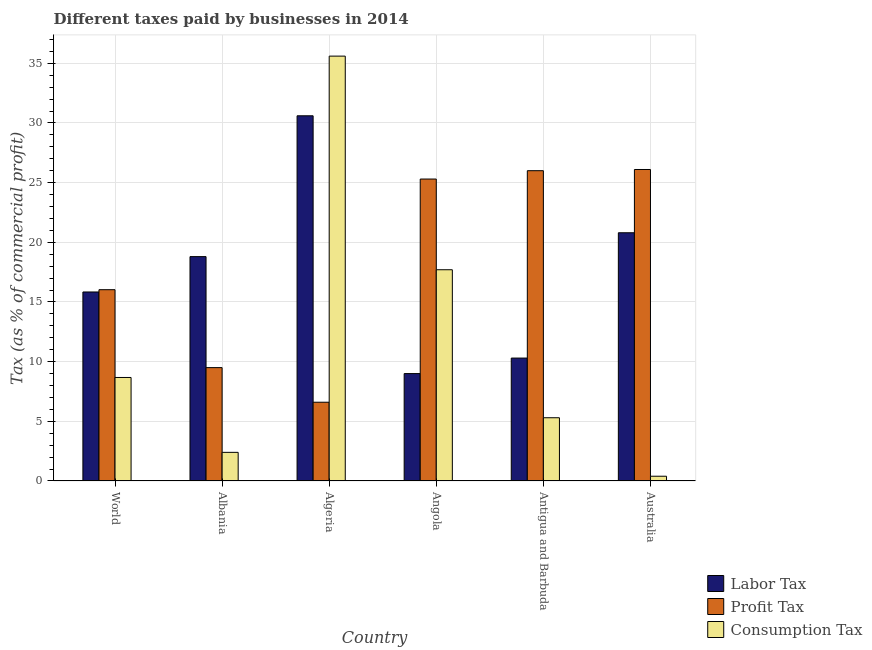How many different coloured bars are there?
Provide a short and direct response. 3. How many groups of bars are there?
Provide a short and direct response. 6. What is the label of the 4th group of bars from the left?
Give a very brief answer. Angola. What is the percentage of consumption tax in World?
Provide a short and direct response. 8.67. Across all countries, what is the maximum percentage of profit tax?
Your answer should be compact. 26.1. In which country was the percentage of consumption tax maximum?
Give a very brief answer. Algeria. In which country was the percentage of profit tax minimum?
Keep it short and to the point. Algeria. What is the total percentage of profit tax in the graph?
Make the answer very short. 109.53. What is the difference between the percentage of labor tax in Albania and that in Australia?
Make the answer very short. -2. What is the difference between the percentage of consumption tax in Algeria and the percentage of profit tax in Albania?
Offer a terse response. 26.1. What is the average percentage of profit tax per country?
Provide a short and direct response. 18.25. What is the difference between the percentage of consumption tax and percentage of labor tax in Australia?
Your answer should be compact. -20.4. What is the ratio of the percentage of consumption tax in Angola to that in Antigua and Barbuda?
Offer a very short reply. 3.34. Is the percentage of profit tax in Australia less than that in World?
Keep it short and to the point. No. Is the difference between the percentage of consumption tax in Algeria and Australia greater than the difference between the percentage of labor tax in Algeria and Australia?
Make the answer very short. Yes. What is the difference between the highest and the second highest percentage of profit tax?
Provide a short and direct response. 0.1. What is the difference between the highest and the lowest percentage of labor tax?
Your response must be concise. 21.6. In how many countries, is the percentage of profit tax greater than the average percentage of profit tax taken over all countries?
Your answer should be compact. 3. Is the sum of the percentage of consumption tax in Angola and World greater than the maximum percentage of labor tax across all countries?
Provide a short and direct response. No. What does the 1st bar from the left in Australia represents?
Provide a succinct answer. Labor Tax. What does the 1st bar from the right in Albania represents?
Offer a very short reply. Consumption Tax. How many bars are there?
Give a very brief answer. 18. How many countries are there in the graph?
Your answer should be compact. 6. What is the difference between two consecutive major ticks on the Y-axis?
Ensure brevity in your answer.  5. Are the values on the major ticks of Y-axis written in scientific E-notation?
Your answer should be compact. No. How many legend labels are there?
Your answer should be compact. 3. What is the title of the graph?
Keep it short and to the point. Different taxes paid by businesses in 2014. Does "Transport equipments" appear as one of the legend labels in the graph?
Offer a terse response. No. What is the label or title of the X-axis?
Your response must be concise. Country. What is the label or title of the Y-axis?
Provide a succinct answer. Tax (as % of commercial profit). What is the Tax (as % of commercial profit) of Labor Tax in World?
Keep it short and to the point. 15.84. What is the Tax (as % of commercial profit) in Profit Tax in World?
Give a very brief answer. 16.03. What is the Tax (as % of commercial profit) of Consumption Tax in World?
Provide a succinct answer. 8.67. What is the Tax (as % of commercial profit) of Labor Tax in Albania?
Make the answer very short. 18.8. What is the Tax (as % of commercial profit) of Consumption Tax in Albania?
Give a very brief answer. 2.4. What is the Tax (as % of commercial profit) of Labor Tax in Algeria?
Make the answer very short. 30.6. What is the Tax (as % of commercial profit) of Consumption Tax in Algeria?
Provide a short and direct response. 35.6. What is the Tax (as % of commercial profit) in Labor Tax in Angola?
Make the answer very short. 9. What is the Tax (as % of commercial profit) of Profit Tax in Angola?
Your response must be concise. 25.3. What is the Tax (as % of commercial profit) of Consumption Tax in Angola?
Your answer should be compact. 17.7. What is the Tax (as % of commercial profit) of Labor Tax in Antigua and Barbuda?
Provide a succinct answer. 10.3. What is the Tax (as % of commercial profit) of Profit Tax in Antigua and Barbuda?
Keep it short and to the point. 26. What is the Tax (as % of commercial profit) in Consumption Tax in Antigua and Barbuda?
Provide a succinct answer. 5.3. What is the Tax (as % of commercial profit) of Labor Tax in Australia?
Give a very brief answer. 20.8. What is the Tax (as % of commercial profit) in Profit Tax in Australia?
Make the answer very short. 26.1. What is the Tax (as % of commercial profit) of Consumption Tax in Australia?
Your answer should be very brief. 0.4. Across all countries, what is the maximum Tax (as % of commercial profit) of Labor Tax?
Offer a terse response. 30.6. Across all countries, what is the maximum Tax (as % of commercial profit) in Profit Tax?
Your response must be concise. 26.1. Across all countries, what is the maximum Tax (as % of commercial profit) of Consumption Tax?
Offer a terse response. 35.6. Across all countries, what is the minimum Tax (as % of commercial profit) of Profit Tax?
Give a very brief answer. 6.6. Across all countries, what is the minimum Tax (as % of commercial profit) in Consumption Tax?
Offer a very short reply. 0.4. What is the total Tax (as % of commercial profit) in Labor Tax in the graph?
Your answer should be very brief. 105.34. What is the total Tax (as % of commercial profit) in Profit Tax in the graph?
Your response must be concise. 109.53. What is the total Tax (as % of commercial profit) in Consumption Tax in the graph?
Your answer should be compact. 70.07. What is the difference between the Tax (as % of commercial profit) of Labor Tax in World and that in Albania?
Give a very brief answer. -2.96. What is the difference between the Tax (as % of commercial profit) in Profit Tax in World and that in Albania?
Your answer should be compact. 6.53. What is the difference between the Tax (as % of commercial profit) in Consumption Tax in World and that in Albania?
Ensure brevity in your answer.  6.27. What is the difference between the Tax (as % of commercial profit) in Labor Tax in World and that in Algeria?
Make the answer very short. -14.76. What is the difference between the Tax (as % of commercial profit) in Profit Tax in World and that in Algeria?
Your answer should be very brief. 9.43. What is the difference between the Tax (as % of commercial profit) in Consumption Tax in World and that in Algeria?
Provide a succinct answer. -26.93. What is the difference between the Tax (as % of commercial profit) of Labor Tax in World and that in Angola?
Ensure brevity in your answer.  6.84. What is the difference between the Tax (as % of commercial profit) of Profit Tax in World and that in Angola?
Keep it short and to the point. -9.27. What is the difference between the Tax (as % of commercial profit) of Consumption Tax in World and that in Angola?
Your answer should be compact. -9.03. What is the difference between the Tax (as % of commercial profit) in Labor Tax in World and that in Antigua and Barbuda?
Your answer should be very brief. 5.54. What is the difference between the Tax (as % of commercial profit) in Profit Tax in World and that in Antigua and Barbuda?
Your answer should be very brief. -9.97. What is the difference between the Tax (as % of commercial profit) of Consumption Tax in World and that in Antigua and Barbuda?
Your answer should be very brief. 3.37. What is the difference between the Tax (as % of commercial profit) of Labor Tax in World and that in Australia?
Your response must be concise. -4.96. What is the difference between the Tax (as % of commercial profit) in Profit Tax in World and that in Australia?
Offer a terse response. -10.07. What is the difference between the Tax (as % of commercial profit) in Consumption Tax in World and that in Australia?
Your answer should be very brief. 8.27. What is the difference between the Tax (as % of commercial profit) of Labor Tax in Albania and that in Algeria?
Provide a short and direct response. -11.8. What is the difference between the Tax (as % of commercial profit) in Consumption Tax in Albania and that in Algeria?
Offer a terse response. -33.2. What is the difference between the Tax (as % of commercial profit) in Profit Tax in Albania and that in Angola?
Keep it short and to the point. -15.8. What is the difference between the Tax (as % of commercial profit) of Consumption Tax in Albania and that in Angola?
Make the answer very short. -15.3. What is the difference between the Tax (as % of commercial profit) in Labor Tax in Albania and that in Antigua and Barbuda?
Offer a terse response. 8.5. What is the difference between the Tax (as % of commercial profit) of Profit Tax in Albania and that in Antigua and Barbuda?
Ensure brevity in your answer.  -16.5. What is the difference between the Tax (as % of commercial profit) of Profit Tax in Albania and that in Australia?
Offer a terse response. -16.6. What is the difference between the Tax (as % of commercial profit) in Consumption Tax in Albania and that in Australia?
Offer a terse response. 2. What is the difference between the Tax (as % of commercial profit) of Labor Tax in Algeria and that in Angola?
Your response must be concise. 21.6. What is the difference between the Tax (as % of commercial profit) of Profit Tax in Algeria and that in Angola?
Your answer should be very brief. -18.7. What is the difference between the Tax (as % of commercial profit) of Labor Tax in Algeria and that in Antigua and Barbuda?
Give a very brief answer. 20.3. What is the difference between the Tax (as % of commercial profit) of Profit Tax in Algeria and that in Antigua and Barbuda?
Make the answer very short. -19.4. What is the difference between the Tax (as % of commercial profit) of Consumption Tax in Algeria and that in Antigua and Barbuda?
Offer a very short reply. 30.3. What is the difference between the Tax (as % of commercial profit) in Profit Tax in Algeria and that in Australia?
Keep it short and to the point. -19.5. What is the difference between the Tax (as % of commercial profit) in Consumption Tax in Algeria and that in Australia?
Offer a terse response. 35.2. What is the difference between the Tax (as % of commercial profit) in Labor Tax in Angola and that in Antigua and Barbuda?
Ensure brevity in your answer.  -1.3. What is the difference between the Tax (as % of commercial profit) of Profit Tax in Angola and that in Antigua and Barbuda?
Make the answer very short. -0.7. What is the difference between the Tax (as % of commercial profit) of Consumption Tax in Angola and that in Antigua and Barbuda?
Provide a short and direct response. 12.4. What is the difference between the Tax (as % of commercial profit) of Consumption Tax in Angola and that in Australia?
Offer a very short reply. 17.3. What is the difference between the Tax (as % of commercial profit) in Labor Tax in Antigua and Barbuda and that in Australia?
Provide a succinct answer. -10.5. What is the difference between the Tax (as % of commercial profit) in Labor Tax in World and the Tax (as % of commercial profit) in Profit Tax in Albania?
Give a very brief answer. 6.34. What is the difference between the Tax (as % of commercial profit) in Labor Tax in World and the Tax (as % of commercial profit) in Consumption Tax in Albania?
Your answer should be very brief. 13.44. What is the difference between the Tax (as % of commercial profit) in Profit Tax in World and the Tax (as % of commercial profit) in Consumption Tax in Albania?
Your response must be concise. 13.63. What is the difference between the Tax (as % of commercial profit) of Labor Tax in World and the Tax (as % of commercial profit) of Profit Tax in Algeria?
Provide a short and direct response. 9.24. What is the difference between the Tax (as % of commercial profit) in Labor Tax in World and the Tax (as % of commercial profit) in Consumption Tax in Algeria?
Provide a succinct answer. -19.76. What is the difference between the Tax (as % of commercial profit) of Profit Tax in World and the Tax (as % of commercial profit) of Consumption Tax in Algeria?
Give a very brief answer. -19.57. What is the difference between the Tax (as % of commercial profit) in Labor Tax in World and the Tax (as % of commercial profit) in Profit Tax in Angola?
Provide a succinct answer. -9.46. What is the difference between the Tax (as % of commercial profit) in Labor Tax in World and the Tax (as % of commercial profit) in Consumption Tax in Angola?
Offer a very short reply. -1.86. What is the difference between the Tax (as % of commercial profit) of Profit Tax in World and the Tax (as % of commercial profit) of Consumption Tax in Angola?
Make the answer very short. -1.67. What is the difference between the Tax (as % of commercial profit) of Labor Tax in World and the Tax (as % of commercial profit) of Profit Tax in Antigua and Barbuda?
Provide a short and direct response. -10.16. What is the difference between the Tax (as % of commercial profit) of Labor Tax in World and the Tax (as % of commercial profit) of Consumption Tax in Antigua and Barbuda?
Provide a succinct answer. 10.54. What is the difference between the Tax (as % of commercial profit) of Profit Tax in World and the Tax (as % of commercial profit) of Consumption Tax in Antigua and Barbuda?
Offer a terse response. 10.73. What is the difference between the Tax (as % of commercial profit) in Labor Tax in World and the Tax (as % of commercial profit) in Profit Tax in Australia?
Ensure brevity in your answer.  -10.26. What is the difference between the Tax (as % of commercial profit) in Labor Tax in World and the Tax (as % of commercial profit) in Consumption Tax in Australia?
Keep it short and to the point. 15.44. What is the difference between the Tax (as % of commercial profit) of Profit Tax in World and the Tax (as % of commercial profit) of Consumption Tax in Australia?
Offer a terse response. 15.63. What is the difference between the Tax (as % of commercial profit) in Labor Tax in Albania and the Tax (as % of commercial profit) in Profit Tax in Algeria?
Your response must be concise. 12.2. What is the difference between the Tax (as % of commercial profit) in Labor Tax in Albania and the Tax (as % of commercial profit) in Consumption Tax in Algeria?
Your answer should be very brief. -16.8. What is the difference between the Tax (as % of commercial profit) of Profit Tax in Albania and the Tax (as % of commercial profit) of Consumption Tax in Algeria?
Give a very brief answer. -26.1. What is the difference between the Tax (as % of commercial profit) in Profit Tax in Albania and the Tax (as % of commercial profit) in Consumption Tax in Angola?
Ensure brevity in your answer.  -8.2. What is the difference between the Tax (as % of commercial profit) in Labor Tax in Albania and the Tax (as % of commercial profit) in Consumption Tax in Antigua and Barbuda?
Provide a short and direct response. 13.5. What is the difference between the Tax (as % of commercial profit) in Profit Tax in Albania and the Tax (as % of commercial profit) in Consumption Tax in Antigua and Barbuda?
Your answer should be very brief. 4.2. What is the difference between the Tax (as % of commercial profit) in Labor Tax in Albania and the Tax (as % of commercial profit) in Profit Tax in Australia?
Offer a very short reply. -7.3. What is the difference between the Tax (as % of commercial profit) in Labor Tax in Albania and the Tax (as % of commercial profit) in Consumption Tax in Australia?
Keep it short and to the point. 18.4. What is the difference between the Tax (as % of commercial profit) of Profit Tax in Albania and the Tax (as % of commercial profit) of Consumption Tax in Australia?
Provide a short and direct response. 9.1. What is the difference between the Tax (as % of commercial profit) of Labor Tax in Algeria and the Tax (as % of commercial profit) of Profit Tax in Angola?
Provide a succinct answer. 5.3. What is the difference between the Tax (as % of commercial profit) in Labor Tax in Algeria and the Tax (as % of commercial profit) in Consumption Tax in Angola?
Offer a terse response. 12.9. What is the difference between the Tax (as % of commercial profit) in Profit Tax in Algeria and the Tax (as % of commercial profit) in Consumption Tax in Angola?
Your answer should be compact. -11.1. What is the difference between the Tax (as % of commercial profit) in Labor Tax in Algeria and the Tax (as % of commercial profit) in Consumption Tax in Antigua and Barbuda?
Provide a succinct answer. 25.3. What is the difference between the Tax (as % of commercial profit) in Profit Tax in Algeria and the Tax (as % of commercial profit) in Consumption Tax in Antigua and Barbuda?
Offer a very short reply. 1.3. What is the difference between the Tax (as % of commercial profit) in Labor Tax in Algeria and the Tax (as % of commercial profit) in Consumption Tax in Australia?
Offer a terse response. 30.2. What is the difference between the Tax (as % of commercial profit) of Labor Tax in Angola and the Tax (as % of commercial profit) of Profit Tax in Antigua and Barbuda?
Ensure brevity in your answer.  -17. What is the difference between the Tax (as % of commercial profit) in Labor Tax in Angola and the Tax (as % of commercial profit) in Profit Tax in Australia?
Give a very brief answer. -17.1. What is the difference between the Tax (as % of commercial profit) of Profit Tax in Angola and the Tax (as % of commercial profit) of Consumption Tax in Australia?
Make the answer very short. 24.9. What is the difference between the Tax (as % of commercial profit) of Labor Tax in Antigua and Barbuda and the Tax (as % of commercial profit) of Profit Tax in Australia?
Give a very brief answer. -15.8. What is the difference between the Tax (as % of commercial profit) of Labor Tax in Antigua and Barbuda and the Tax (as % of commercial profit) of Consumption Tax in Australia?
Your answer should be compact. 9.9. What is the difference between the Tax (as % of commercial profit) in Profit Tax in Antigua and Barbuda and the Tax (as % of commercial profit) in Consumption Tax in Australia?
Offer a very short reply. 25.6. What is the average Tax (as % of commercial profit) of Labor Tax per country?
Give a very brief answer. 17.56. What is the average Tax (as % of commercial profit) in Profit Tax per country?
Your answer should be compact. 18.25. What is the average Tax (as % of commercial profit) of Consumption Tax per country?
Provide a succinct answer. 11.68. What is the difference between the Tax (as % of commercial profit) in Labor Tax and Tax (as % of commercial profit) in Profit Tax in World?
Provide a short and direct response. -0.19. What is the difference between the Tax (as % of commercial profit) of Labor Tax and Tax (as % of commercial profit) of Consumption Tax in World?
Offer a terse response. 7.16. What is the difference between the Tax (as % of commercial profit) in Profit Tax and Tax (as % of commercial profit) in Consumption Tax in World?
Provide a succinct answer. 7.36. What is the difference between the Tax (as % of commercial profit) of Labor Tax and Tax (as % of commercial profit) of Consumption Tax in Albania?
Your answer should be very brief. 16.4. What is the difference between the Tax (as % of commercial profit) in Profit Tax and Tax (as % of commercial profit) in Consumption Tax in Albania?
Offer a very short reply. 7.1. What is the difference between the Tax (as % of commercial profit) in Labor Tax and Tax (as % of commercial profit) in Profit Tax in Algeria?
Provide a short and direct response. 24. What is the difference between the Tax (as % of commercial profit) of Labor Tax and Tax (as % of commercial profit) of Consumption Tax in Algeria?
Your answer should be very brief. -5. What is the difference between the Tax (as % of commercial profit) in Profit Tax and Tax (as % of commercial profit) in Consumption Tax in Algeria?
Your response must be concise. -29. What is the difference between the Tax (as % of commercial profit) of Labor Tax and Tax (as % of commercial profit) of Profit Tax in Angola?
Give a very brief answer. -16.3. What is the difference between the Tax (as % of commercial profit) in Labor Tax and Tax (as % of commercial profit) in Consumption Tax in Angola?
Your answer should be compact. -8.7. What is the difference between the Tax (as % of commercial profit) in Profit Tax and Tax (as % of commercial profit) in Consumption Tax in Angola?
Ensure brevity in your answer.  7.6. What is the difference between the Tax (as % of commercial profit) of Labor Tax and Tax (as % of commercial profit) of Profit Tax in Antigua and Barbuda?
Your answer should be compact. -15.7. What is the difference between the Tax (as % of commercial profit) in Labor Tax and Tax (as % of commercial profit) in Consumption Tax in Antigua and Barbuda?
Make the answer very short. 5. What is the difference between the Tax (as % of commercial profit) in Profit Tax and Tax (as % of commercial profit) in Consumption Tax in Antigua and Barbuda?
Your answer should be very brief. 20.7. What is the difference between the Tax (as % of commercial profit) in Labor Tax and Tax (as % of commercial profit) in Consumption Tax in Australia?
Offer a terse response. 20.4. What is the difference between the Tax (as % of commercial profit) in Profit Tax and Tax (as % of commercial profit) in Consumption Tax in Australia?
Your answer should be very brief. 25.7. What is the ratio of the Tax (as % of commercial profit) of Labor Tax in World to that in Albania?
Offer a terse response. 0.84. What is the ratio of the Tax (as % of commercial profit) of Profit Tax in World to that in Albania?
Provide a short and direct response. 1.69. What is the ratio of the Tax (as % of commercial profit) in Consumption Tax in World to that in Albania?
Your answer should be very brief. 3.61. What is the ratio of the Tax (as % of commercial profit) of Labor Tax in World to that in Algeria?
Offer a very short reply. 0.52. What is the ratio of the Tax (as % of commercial profit) in Profit Tax in World to that in Algeria?
Provide a short and direct response. 2.43. What is the ratio of the Tax (as % of commercial profit) of Consumption Tax in World to that in Algeria?
Offer a very short reply. 0.24. What is the ratio of the Tax (as % of commercial profit) of Labor Tax in World to that in Angola?
Provide a succinct answer. 1.76. What is the ratio of the Tax (as % of commercial profit) in Profit Tax in World to that in Angola?
Provide a short and direct response. 0.63. What is the ratio of the Tax (as % of commercial profit) of Consumption Tax in World to that in Angola?
Offer a very short reply. 0.49. What is the ratio of the Tax (as % of commercial profit) of Labor Tax in World to that in Antigua and Barbuda?
Give a very brief answer. 1.54. What is the ratio of the Tax (as % of commercial profit) in Profit Tax in World to that in Antigua and Barbuda?
Provide a short and direct response. 0.62. What is the ratio of the Tax (as % of commercial profit) in Consumption Tax in World to that in Antigua and Barbuda?
Your answer should be compact. 1.64. What is the ratio of the Tax (as % of commercial profit) of Labor Tax in World to that in Australia?
Keep it short and to the point. 0.76. What is the ratio of the Tax (as % of commercial profit) of Profit Tax in World to that in Australia?
Keep it short and to the point. 0.61. What is the ratio of the Tax (as % of commercial profit) in Consumption Tax in World to that in Australia?
Give a very brief answer. 21.68. What is the ratio of the Tax (as % of commercial profit) in Labor Tax in Albania to that in Algeria?
Keep it short and to the point. 0.61. What is the ratio of the Tax (as % of commercial profit) in Profit Tax in Albania to that in Algeria?
Offer a very short reply. 1.44. What is the ratio of the Tax (as % of commercial profit) in Consumption Tax in Albania to that in Algeria?
Provide a succinct answer. 0.07. What is the ratio of the Tax (as % of commercial profit) in Labor Tax in Albania to that in Angola?
Your response must be concise. 2.09. What is the ratio of the Tax (as % of commercial profit) in Profit Tax in Albania to that in Angola?
Offer a very short reply. 0.38. What is the ratio of the Tax (as % of commercial profit) in Consumption Tax in Albania to that in Angola?
Your answer should be very brief. 0.14. What is the ratio of the Tax (as % of commercial profit) in Labor Tax in Albania to that in Antigua and Barbuda?
Provide a succinct answer. 1.83. What is the ratio of the Tax (as % of commercial profit) of Profit Tax in Albania to that in Antigua and Barbuda?
Provide a succinct answer. 0.37. What is the ratio of the Tax (as % of commercial profit) in Consumption Tax in Albania to that in Antigua and Barbuda?
Give a very brief answer. 0.45. What is the ratio of the Tax (as % of commercial profit) of Labor Tax in Albania to that in Australia?
Offer a terse response. 0.9. What is the ratio of the Tax (as % of commercial profit) of Profit Tax in Albania to that in Australia?
Your response must be concise. 0.36. What is the ratio of the Tax (as % of commercial profit) in Profit Tax in Algeria to that in Angola?
Make the answer very short. 0.26. What is the ratio of the Tax (as % of commercial profit) in Consumption Tax in Algeria to that in Angola?
Offer a terse response. 2.01. What is the ratio of the Tax (as % of commercial profit) in Labor Tax in Algeria to that in Antigua and Barbuda?
Keep it short and to the point. 2.97. What is the ratio of the Tax (as % of commercial profit) in Profit Tax in Algeria to that in Antigua and Barbuda?
Ensure brevity in your answer.  0.25. What is the ratio of the Tax (as % of commercial profit) of Consumption Tax in Algeria to that in Antigua and Barbuda?
Provide a succinct answer. 6.72. What is the ratio of the Tax (as % of commercial profit) of Labor Tax in Algeria to that in Australia?
Your response must be concise. 1.47. What is the ratio of the Tax (as % of commercial profit) of Profit Tax in Algeria to that in Australia?
Provide a succinct answer. 0.25. What is the ratio of the Tax (as % of commercial profit) of Consumption Tax in Algeria to that in Australia?
Provide a succinct answer. 89. What is the ratio of the Tax (as % of commercial profit) of Labor Tax in Angola to that in Antigua and Barbuda?
Provide a short and direct response. 0.87. What is the ratio of the Tax (as % of commercial profit) of Profit Tax in Angola to that in Antigua and Barbuda?
Provide a succinct answer. 0.97. What is the ratio of the Tax (as % of commercial profit) of Consumption Tax in Angola to that in Antigua and Barbuda?
Ensure brevity in your answer.  3.34. What is the ratio of the Tax (as % of commercial profit) of Labor Tax in Angola to that in Australia?
Provide a succinct answer. 0.43. What is the ratio of the Tax (as % of commercial profit) in Profit Tax in Angola to that in Australia?
Ensure brevity in your answer.  0.97. What is the ratio of the Tax (as % of commercial profit) of Consumption Tax in Angola to that in Australia?
Make the answer very short. 44.25. What is the ratio of the Tax (as % of commercial profit) in Labor Tax in Antigua and Barbuda to that in Australia?
Give a very brief answer. 0.5. What is the ratio of the Tax (as % of commercial profit) in Consumption Tax in Antigua and Barbuda to that in Australia?
Give a very brief answer. 13.25. What is the difference between the highest and the second highest Tax (as % of commercial profit) in Labor Tax?
Make the answer very short. 9.8. What is the difference between the highest and the second highest Tax (as % of commercial profit) of Profit Tax?
Your response must be concise. 0.1. What is the difference between the highest and the second highest Tax (as % of commercial profit) in Consumption Tax?
Your answer should be very brief. 17.9. What is the difference between the highest and the lowest Tax (as % of commercial profit) of Labor Tax?
Provide a succinct answer. 21.6. What is the difference between the highest and the lowest Tax (as % of commercial profit) of Profit Tax?
Your answer should be very brief. 19.5. What is the difference between the highest and the lowest Tax (as % of commercial profit) in Consumption Tax?
Offer a terse response. 35.2. 